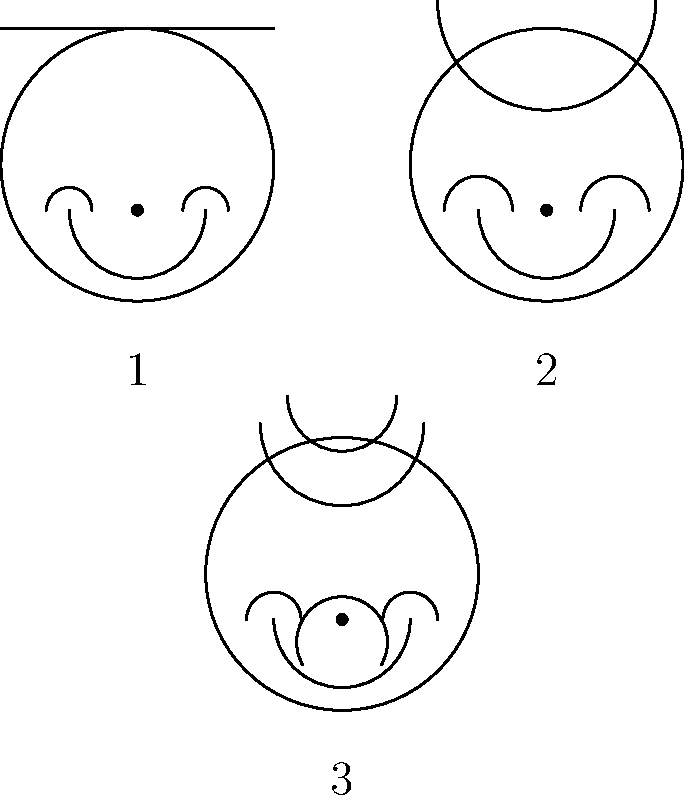As a talent show judge focused on instant stardom, which hairstyle and makeup combination would you choose for a contestant to create the most camera-ready and attention-grabbing look? To determine the most camera-ready and attention-grabbing look, let's analyze each option:

1. Option 1:
   - Hair: Straight, angular cut
   - Makeup: Subtle eye makeup
   - Effect: Clean and simple, but may not stand out on camera

2. Option 2:
   - Hair: Voluminous, rounded style
   - Makeup: More pronounced eye makeup
   - Effect: Adds dimension and draws attention to the eyes

3. Option 3:
   - Hair: Layered, textured style
   - Makeup: Dramatic eye makeup with defined lips
   - Effect: Creates depth, texture, and multiple focal points

For instant stardom and maximum camera impact:
- Hair should have volume and movement
- Makeup should be bold and eye-catching
- Overall look should be memorable and stand out on screen

Option 3 best meets these criteria:
- The layered hairstyle adds volume and texture
- The dramatic eye makeup draws attention to the eyes
- The defined lips create an additional focal point
- The combination is the most likely to be noticed and remembered by viewers

This look will create the most visual interest on camera and help the contestant stand out, which aligns with the goal of instant fame in a talent show setting.
Answer: Option 3 